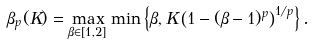<formula> <loc_0><loc_0><loc_500><loc_500>\beta _ { p } ( K ) = \max _ { \beta \in [ 1 , 2 ] } \min \left \{ \beta , K \left ( 1 - ( \beta - 1 ) ^ { p } \right ) ^ { 1 / p } \right \} .</formula> 